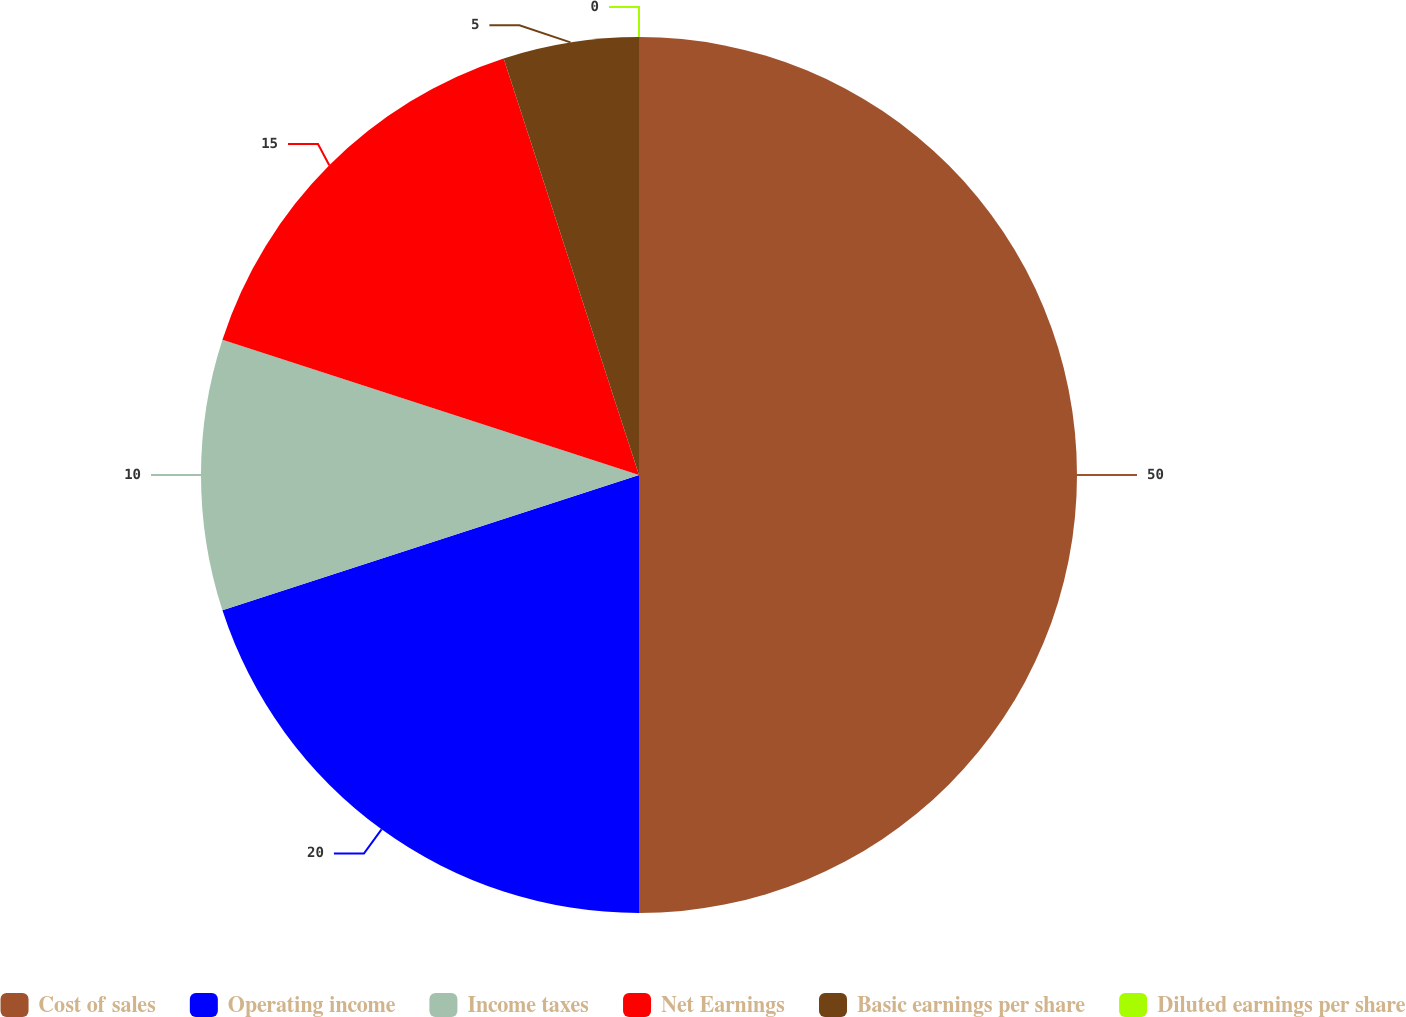Convert chart to OTSL. <chart><loc_0><loc_0><loc_500><loc_500><pie_chart><fcel>Cost of sales<fcel>Operating income<fcel>Income taxes<fcel>Net Earnings<fcel>Basic earnings per share<fcel>Diluted earnings per share<nl><fcel>50.0%<fcel>20.0%<fcel>10.0%<fcel>15.0%<fcel>5.0%<fcel>0.0%<nl></chart> 